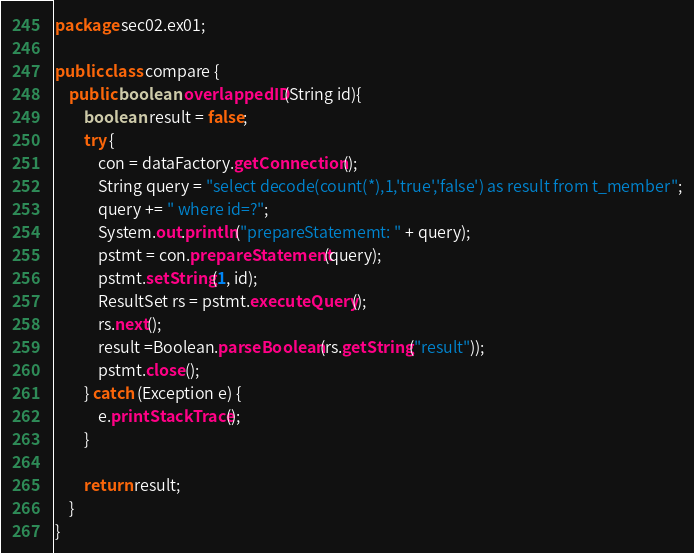Convert code to text. <code><loc_0><loc_0><loc_500><loc_500><_Java_>package sec02.ex01;

public class compare {
	public boolean overlappedID(String id){
		boolean result = false;
		try {
			con = dataFactory.getConnection();
			String query = "select decode(count(*),1,'true','false') as result from t_member";
			query += " where id=?";
			System.out.println("prepareStatememt: " + query);
			pstmt = con.prepareStatement(query);
			pstmt.setString(1, id);
			ResultSet rs = pstmt.executeQuery();
			rs.next();
			result =Boolean.parseBoolean(rs.getString("result"));
			pstmt.close();
		} catch (Exception e) {
			e.printStackTrace();
		}
		
		return result;
	}
}
</code> 